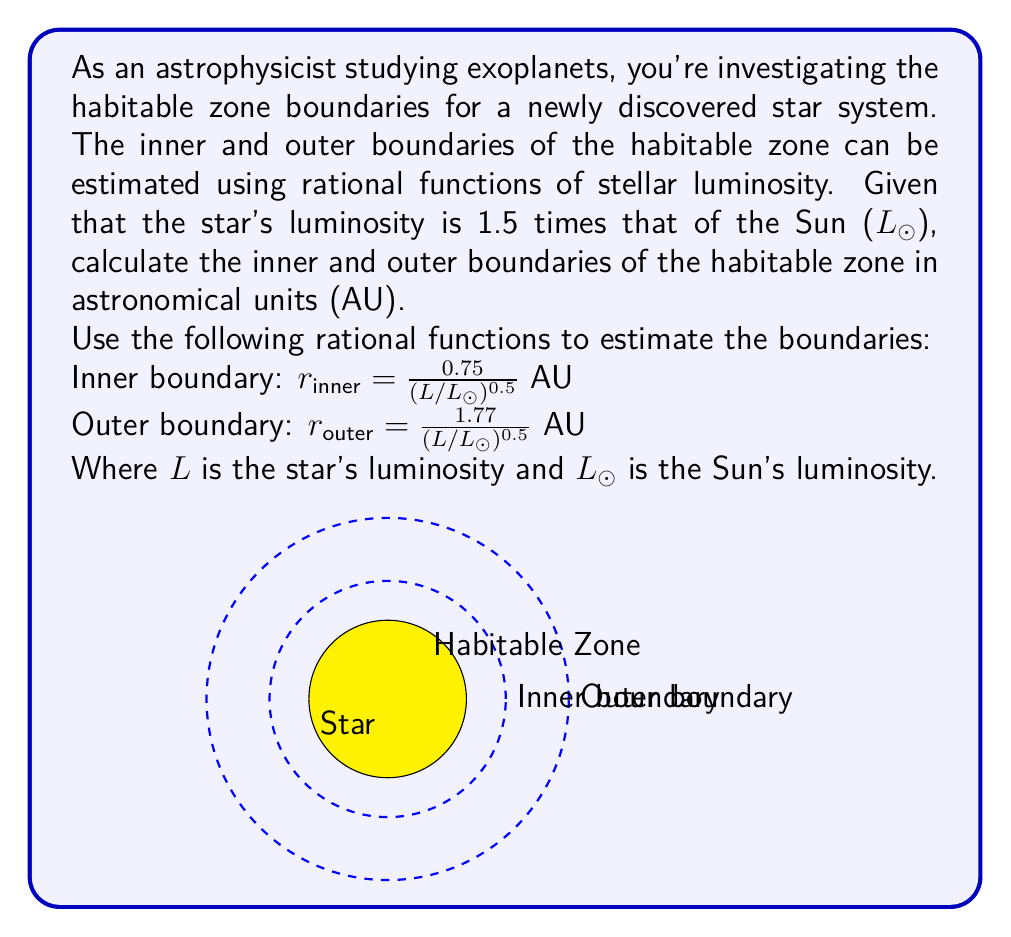Solve this math problem. Let's approach this step-by-step:

1. We're given that the star's luminosity is 1.5 times that of the Sun, so:
   $L = 1.5L_{\odot}$

2. For the inner boundary:
   $$r_{inner} = \frac{0.75}{(L/L_{\odot})^{0.5}}$$
   
   Substituting the luminosity:
   $$r_{inner} = \frac{0.75}{(1.5)^{0.5}}$$
   
   Simplify:
   $$r_{inner} = \frac{0.75}{\sqrt{1.5}} = \frac{0.75}{1.225} \approx 0.612 \text{ AU}$$

3. For the outer boundary:
   $$r_{outer} = \frac{1.77}{(L/L_{\odot})^{0.5}}$$
   
   Substituting the luminosity:
   $$r_{outer} = \frac{1.77}{(1.5)^{0.5}}$$
   
   Simplify:
   $$r_{outer} = \frac{1.77}{\sqrt{1.5}} = \frac{1.77}{1.225} \approx 1.445 \text{ AU}$$

Thus, the habitable zone for this star system extends from approximately 0.612 AU to 1.445 AU.
Answer: Inner boundary: 0.612 AU, Outer boundary: 1.445 AU 